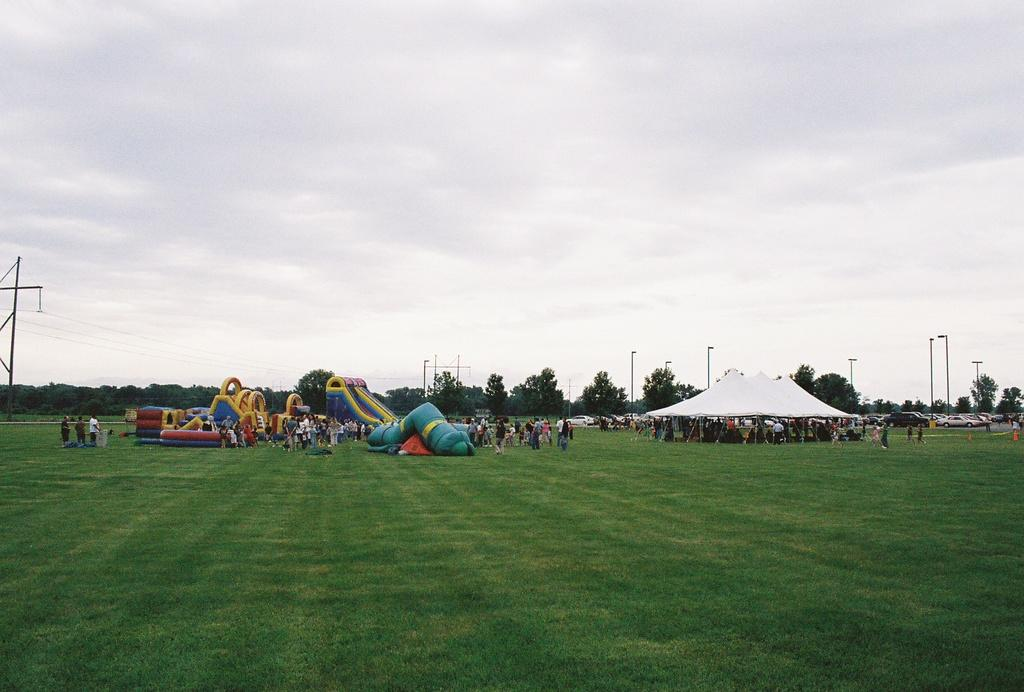What is the condition of the sky in the image? The sky is cloudy in the image. What type of vegetation covers the land in the image? The land is covered with grass in the image. Can you identify any human presence in the image? Yes, there are people in the distance in the image. What structures can be seen in the distance? There is a tent, light poles, and vehicles in the distance in the image. Are there any natural elements visible in the distance? Yes, there are trees in the distance in the image. What type of recreational items are present in the distance? There are inflatables in the distance in the image. What type of building is visible in the image? There is no building visible in the image; it features a cloudy sky, grass-covered land, and various elements in the distance. What causes the inflatables to burst in the image? There is no indication of any inflatables bursting in the image. 